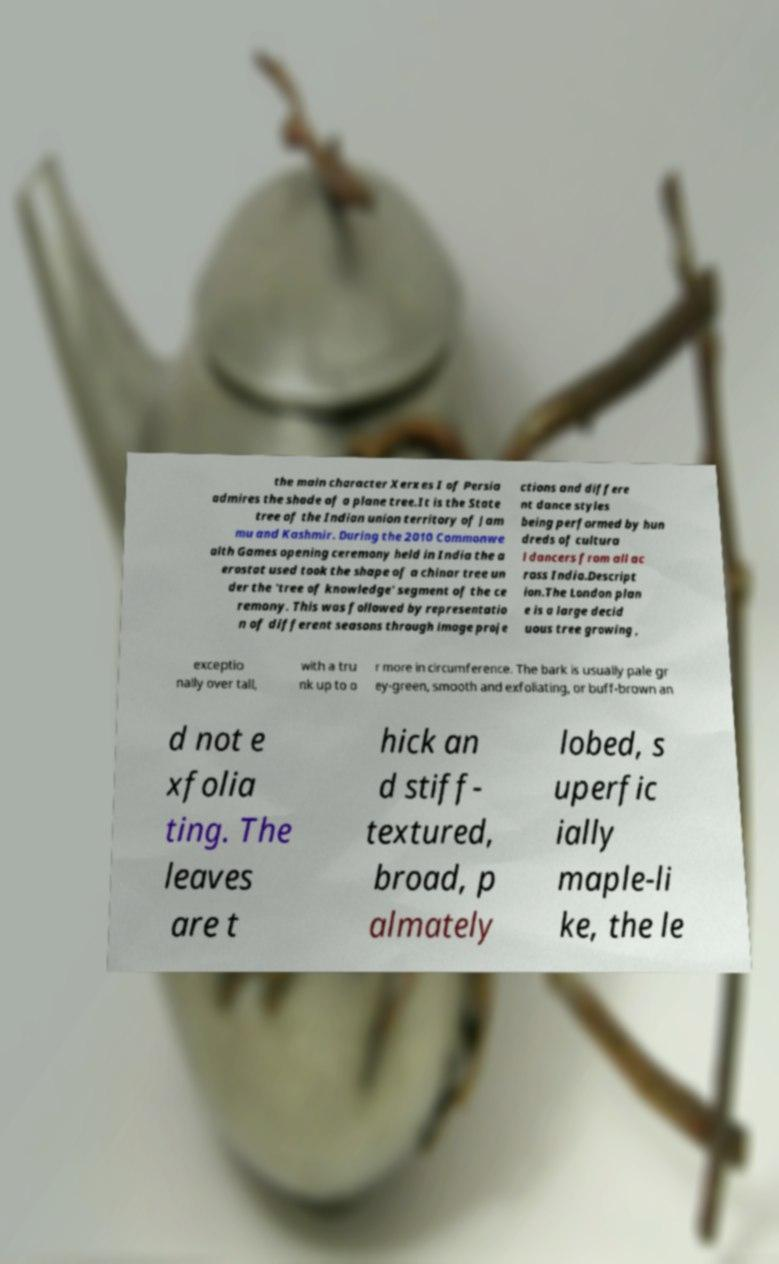I need the written content from this picture converted into text. Can you do that? the main character Xerxes I of Persia admires the shade of a plane tree.It is the State tree of the Indian union territory of Jam mu and Kashmir. During the 2010 Commonwe alth Games opening ceremony held in India the a erostat used took the shape of a chinar tree un der the 'tree of knowledge' segment of the ce remony. This was followed by representatio n of different seasons through image proje ctions and differe nt dance styles being performed by hun dreds of cultura l dancers from all ac ross India.Descript ion.The London plan e is a large decid uous tree growing , exceptio nally over tall, with a tru nk up to o r more in circumference. The bark is usually pale gr ey-green, smooth and exfoliating, or buff-brown an d not e xfolia ting. The leaves are t hick an d stiff- textured, broad, p almately lobed, s uperfic ially maple-li ke, the le 